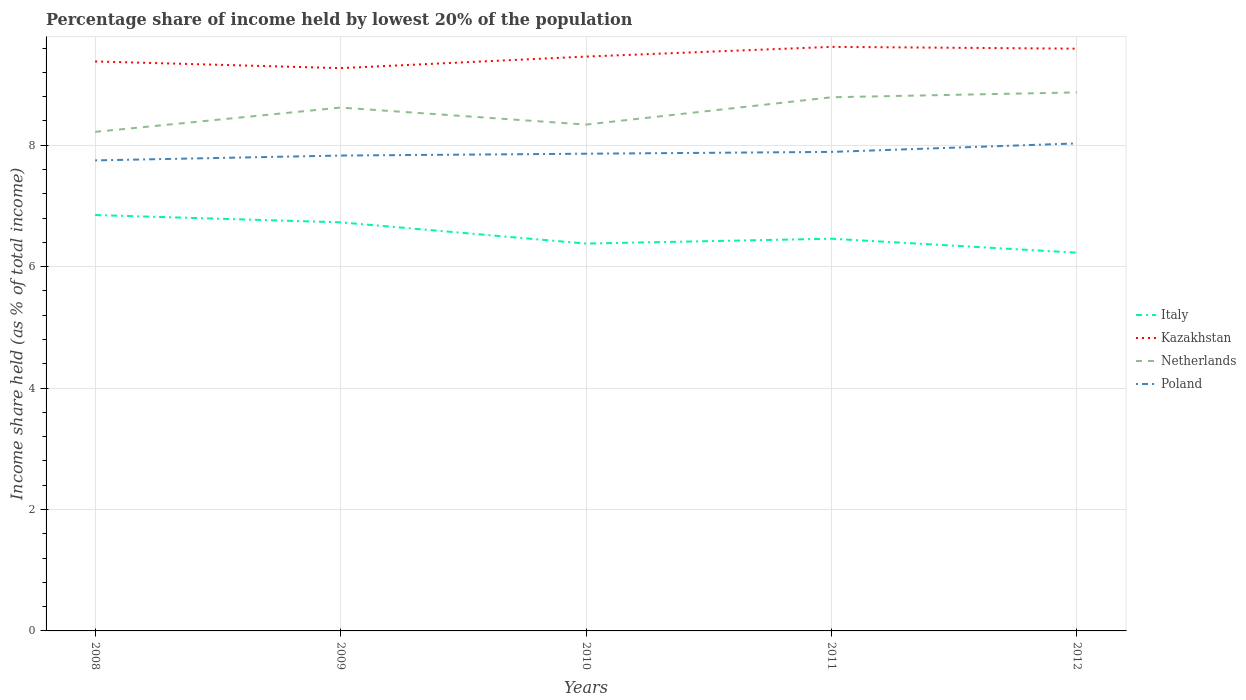Across all years, what is the maximum percentage share of income held by lowest 20% of the population in Italy?
Your response must be concise. 6.23. What is the total percentage share of income held by lowest 20% of the population in Netherlands in the graph?
Your answer should be compact. -0.12. What is the difference between the highest and the second highest percentage share of income held by lowest 20% of the population in Poland?
Your answer should be compact. 0.28. What is the difference between the highest and the lowest percentage share of income held by lowest 20% of the population in Kazakhstan?
Offer a terse response. 2. Is the percentage share of income held by lowest 20% of the population in Italy strictly greater than the percentage share of income held by lowest 20% of the population in Kazakhstan over the years?
Give a very brief answer. Yes. How many years are there in the graph?
Make the answer very short. 5. Are the values on the major ticks of Y-axis written in scientific E-notation?
Keep it short and to the point. No. Does the graph contain any zero values?
Keep it short and to the point. No. Where does the legend appear in the graph?
Provide a short and direct response. Center right. How many legend labels are there?
Ensure brevity in your answer.  4. How are the legend labels stacked?
Your answer should be compact. Vertical. What is the title of the graph?
Keep it short and to the point. Percentage share of income held by lowest 20% of the population. What is the label or title of the X-axis?
Keep it short and to the point. Years. What is the label or title of the Y-axis?
Give a very brief answer. Income share held (as % of total income). What is the Income share held (as % of total income) of Italy in 2008?
Offer a terse response. 6.85. What is the Income share held (as % of total income) of Kazakhstan in 2008?
Ensure brevity in your answer.  9.38. What is the Income share held (as % of total income) of Netherlands in 2008?
Your answer should be very brief. 8.22. What is the Income share held (as % of total income) of Poland in 2008?
Your response must be concise. 7.75. What is the Income share held (as % of total income) in Italy in 2009?
Ensure brevity in your answer.  6.73. What is the Income share held (as % of total income) in Kazakhstan in 2009?
Offer a terse response. 9.27. What is the Income share held (as % of total income) of Netherlands in 2009?
Provide a short and direct response. 8.62. What is the Income share held (as % of total income) of Poland in 2009?
Give a very brief answer. 7.83. What is the Income share held (as % of total income) of Italy in 2010?
Offer a very short reply. 6.38. What is the Income share held (as % of total income) in Kazakhstan in 2010?
Offer a terse response. 9.46. What is the Income share held (as % of total income) of Netherlands in 2010?
Your response must be concise. 8.34. What is the Income share held (as % of total income) in Poland in 2010?
Make the answer very short. 7.86. What is the Income share held (as % of total income) of Italy in 2011?
Your answer should be very brief. 6.46. What is the Income share held (as % of total income) in Kazakhstan in 2011?
Give a very brief answer. 9.62. What is the Income share held (as % of total income) in Netherlands in 2011?
Your answer should be compact. 8.79. What is the Income share held (as % of total income) of Poland in 2011?
Your answer should be very brief. 7.89. What is the Income share held (as % of total income) in Italy in 2012?
Give a very brief answer. 6.23. What is the Income share held (as % of total income) in Kazakhstan in 2012?
Provide a succinct answer. 9.59. What is the Income share held (as % of total income) in Netherlands in 2012?
Give a very brief answer. 8.87. What is the Income share held (as % of total income) in Poland in 2012?
Your response must be concise. 8.03. Across all years, what is the maximum Income share held (as % of total income) in Italy?
Your answer should be very brief. 6.85. Across all years, what is the maximum Income share held (as % of total income) in Kazakhstan?
Your answer should be very brief. 9.62. Across all years, what is the maximum Income share held (as % of total income) in Netherlands?
Give a very brief answer. 8.87. Across all years, what is the maximum Income share held (as % of total income) of Poland?
Provide a short and direct response. 8.03. Across all years, what is the minimum Income share held (as % of total income) of Italy?
Provide a succinct answer. 6.23. Across all years, what is the minimum Income share held (as % of total income) in Kazakhstan?
Keep it short and to the point. 9.27. Across all years, what is the minimum Income share held (as % of total income) of Netherlands?
Offer a very short reply. 8.22. Across all years, what is the minimum Income share held (as % of total income) in Poland?
Provide a succinct answer. 7.75. What is the total Income share held (as % of total income) in Italy in the graph?
Offer a very short reply. 32.65. What is the total Income share held (as % of total income) of Kazakhstan in the graph?
Your response must be concise. 47.32. What is the total Income share held (as % of total income) of Netherlands in the graph?
Provide a short and direct response. 42.84. What is the total Income share held (as % of total income) in Poland in the graph?
Offer a very short reply. 39.36. What is the difference between the Income share held (as % of total income) of Italy in 2008 and that in 2009?
Offer a terse response. 0.12. What is the difference between the Income share held (as % of total income) in Kazakhstan in 2008 and that in 2009?
Your response must be concise. 0.11. What is the difference between the Income share held (as % of total income) of Poland in 2008 and that in 2009?
Your response must be concise. -0.08. What is the difference between the Income share held (as % of total income) in Italy in 2008 and that in 2010?
Ensure brevity in your answer.  0.47. What is the difference between the Income share held (as % of total income) of Kazakhstan in 2008 and that in 2010?
Your answer should be compact. -0.08. What is the difference between the Income share held (as % of total income) in Netherlands in 2008 and that in 2010?
Your response must be concise. -0.12. What is the difference between the Income share held (as % of total income) of Poland in 2008 and that in 2010?
Offer a terse response. -0.11. What is the difference between the Income share held (as % of total income) in Italy in 2008 and that in 2011?
Offer a very short reply. 0.39. What is the difference between the Income share held (as % of total income) in Kazakhstan in 2008 and that in 2011?
Give a very brief answer. -0.24. What is the difference between the Income share held (as % of total income) of Netherlands in 2008 and that in 2011?
Your answer should be very brief. -0.57. What is the difference between the Income share held (as % of total income) in Poland in 2008 and that in 2011?
Your answer should be very brief. -0.14. What is the difference between the Income share held (as % of total income) of Italy in 2008 and that in 2012?
Provide a succinct answer. 0.62. What is the difference between the Income share held (as % of total income) of Kazakhstan in 2008 and that in 2012?
Give a very brief answer. -0.21. What is the difference between the Income share held (as % of total income) of Netherlands in 2008 and that in 2012?
Provide a short and direct response. -0.65. What is the difference between the Income share held (as % of total income) in Poland in 2008 and that in 2012?
Your response must be concise. -0.28. What is the difference between the Income share held (as % of total income) of Italy in 2009 and that in 2010?
Your answer should be very brief. 0.35. What is the difference between the Income share held (as % of total income) of Kazakhstan in 2009 and that in 2010?
Provide a short and direct response. -0.19. What is the difference between the Income share held (as % of total income) of Netherlands in 2009 and that in 2010?
Make the answer very short. 0.28. What is the difference between the Income share held (as % of total income) in Poland in 2009 and that in 2010?
Your answer should be compact. -0.03. What is the difference between the Income share held (as % of total income) of Italy in 2009 and that in 2011?
Your answer should be very brief. 0.27. What is the difference between the Income share held (as % of total income) in Kazakhstan in 2009 and that in 2011?
Offer a very short reply. -0.35. What is the difference between the Income share held (as % of total income) in Netherlands in 2009 and that in 2011?
Offer a terse response. -0.17. What is the difference between the Income share held (as % of total income) of Poland in 2009 and that in 2011?
Your answer should be very brief. -0.06. What is the difference between the Income share held (as % of total income) in Italy in 2009 and that in 2012?
Make the answer very short. 0.5. What is the difference between the Income share held (as % of total income) of Kazakhstan in 2009 and that in 2012?
Offer a terse response. -0.32. What is the difference between the Income share held (as % of total income) in Italy in 2010 and that in 2011?
Ensure brevity in your answer.  -0.08. What is the difference between the Income share held (as % of total income) of Kazakhstan in 2010 and that in 2011?
Give a very brief answer. -0.16. What is the difference between the Income share held (as % of total income) in Netherlands in 2010 and that in 2011?
Offer a terse response. -0.45. What is the difference between the Income share held (as % of total income) in Poland in 2010 and that in 2011?
Offer a terse response. -0.03. What is the difference between the Income share held (as % of total income) in Italy in 2010 and that in 2012?
Provide a succinct answer. 0.15. What is the difference between the Income share held (as % of total income) of Kazakhstan in 2010 and that in 2012?
Offer a very short reply. -0.13. What is the difference between the Income share held (as % of total income) of Netherlands in 2010 and that in 2012?
Your answer should be very brief. -0.53. What is the difference between the Income share held (as % of total income) in Poland in 2010 and that in 2012?
Offer a terse response. -0.17. What is the difference between the Income share held (as % of total income) in Italy in 2011 and that in 2012?
Your answer should be very brief. 0.23. What is the difference between the Income share held (as % of total income) of Kazakhstan in 2011 and that in 2012?
Ensure brevity in your answer.  0.03. What is the difference between the Income share held (as % of total income) in Netherlands in 2011 and that in 2012?
Keep it short and to the point. -0.08. What is the difference between the Income share held (as % of total income) in Poland in 2011 and that in 2012?
Your response must be concise. -0.14. What is the difference between the Income share held (as % of total income) in Italy in 2008 and the Income share held (as % of total income) in Kazakhstan in 2009?
Your answer should be very brief. -2.42. What is the difference between the Income share held (as % of total income) of Italy in 2008 and the Income share held (as % of total income) of Netherlands in 2009?
Make the answer very short. -1.77. What is the difference between the Income share held (as % of total income) in Italy in 2008 and the Income share held (as % of total income) in Poland in 2009?
Give a very brief answer. -0.98. What is the difference between the Income share held (as % of total income) of Kazakhstan in 2008 and the Income share held (as % of total income) of Netherlands in 2009?
Keep it short and to the point. 0.76. What is the difference between the Income share held (as % of total income) in Kazakhstan in 2008 and the Income share held (as % of total income) in Poland in 2009?
Your response must be concise. 1.55. What is the difference between the Income share held (as % of total income) of Netherlands in 2008 and the Income share held (as % of total income) of Poland in 2009?
Your answer should be compact. 0.39. What is the difference between the Income share held (as % of total income) in Italy in 2008 and the Income share held (as % of total income) in Kazakhstan in 2010?
Your response must be concise. -2.61. What is the difference between the Income share held (as % of total income) in Italy in 2008 and the Income share held (as % of total income) in Netherlands in 2010?
Your answer should be compact. -1.49. What is the difference between the Income share held (as % of total income) of Italy in 2008 and the Income share held (as % of total income) of Poland in 2010?
Ensure brevity in your answer.  -1.01. What is the difference between the Income share held (as % of total income) in Kazakhstan in 2008 and the Income share held (as % of total income) in Netherlands in 2010?
Your answer should be very brief. 1.04. What is the difference between the Income share held (as % of total income) of Kazakhstan in 2008 and the Income share held (as % of total income) of Poland in 2010?
Your answer should be very brief. 1.52. What is the difference between the Income share held (as % of total income) of Netherlands in 2008 and the Income share held (as % of total income) of Poland in 2010?
Your response must be concise. 0.36. What is the difference between the Income share held (as % of total income) of Italy in 2008 and the Income share held (as % of total income) of Kazakhstan in 2011?
Offer a very short reply. -2.77. What is the difference between the Income share held (as % of total income) of Italy in 2008 and the Income share held (as % of total income) of Netherlands in 2011?
Your answer should be very brief. -1.94. What is the difference between the Income share held (as % of total income) in Italy in 2008 and the Income share held (as % of total income) in Poland in 2011?
Provide a short and direct response. -1.04. What is the difference between the Income share held (as % of total income) in Kazakhstan in 2008 and the Income share held (as % of total income) in Netherlands in 2011?
Keep it short and to the point. 0.59. What is the difference between the Income share held (as % of total income) of Kazakhstan in 2008 and the Income share held (as % of total income) of Poland in 2011?
Offer a terse response. 1.49. What is the difference between the Income share held (as % of total income) in Netherlands in 2008 and the Income share held (as % of total income) in Poland in 2011?
Ensure brevity in your answer.  0.33. What is the difference between the Income share held (as % of total income) in Italy in 2008 and the Income share held (as % of total income) in Kazakhstan in 2012?
Your response must be concise. -2.74. What is the difference between the Income share held (as % of total income) in Italy in 2008 and the Income share held (as % of total income) in Netherlands in 2012?
Offer a terse response. -2.02. What is the difference between the Income share held (as % of total income) of Italy in 2008 and the Income share held (as % of total income) of Poland in 2012?
Keep it short and to the point. -1.18. What is the difference between the Income share held (as % of total income) in Kazakhstan in 2008 and the Income share held (as % of total income) in Netherlands in 2012?
Offer a very short reply. 0.51. What is the difference between the Income share held (as % of total income) in Kazakhstan in 2008 and the Income share held (as % of total income) in Poland in 2012?
Offer a very short reply. 1.35. What is the difference between the Income share held (as % of total income) of Netherlands in 2008 and the Income share held (as % of total income) of Poland in 2012?
Your answer should be very brief. 0.19. What is the difference between the Income share held (as % of total income) of Italy in 2009 and the Income share held (as % of total income) of Kazakhstan in 2010?
Your response must be concise. -2.73. What is the difference between the Income share held (as % of total income) of Italy in 2009 and the Income share held (as % of total income) of Netherlands in 2010?
Ensure brevity in your answer.  -1.61. What is the difference between the Income share held (as % of total income) of Italy in 2009 and the Income share held (as % of total income) of Poland in 2010?
Make the answer very short. -1.13. What is the difference between the Income share held (as % of total income) in Kazakhstan in 2009 and the Income share held (as % of total income) in Netherlands in 2010?
Offer a very short reply. 0.93. What is the difference between the Income share held (as % of total income) of Kazakhstan in 2009 and the Income share held (as % of total income) of Poland in 2010?
Keep it short and to the point. 1.41. What is the difference between the Income share held (as % of total income) of Netherlands in 2009 and the Income share held (as % of total income) of Poland in 2010?
Provide a succinct answer. 0.76. What is the difference between the Income share held (as % of total income) in Italy in 2009 and the Income share held (as % of total income) in Kazakhstan in 2011?
Your answer should be very brief. -2.89. What is the difference between the Income share held (as % of total income) in Italy in 2009 and the Income share held (as % of total income) in Netherlands in 2011?
Make the answer very short. -2.06. What is the difference between the Income share held (as % of total income) of Italy in 2009 and the Income share held (as % of total income) of Poland in 2011?
Offer a very short reply. -1.16. What is the difference between the Income share held (as % of total income) of Kazakhstan in 2009 and the Income share held (as % of total income) of Netherlands in 2011?
Give a very brief answer. 0.48. What is the difference between the Income share held (as % of total income) in Kazakhstan in 2009 and the Income share held (as % of total income) in Poland in 2011?
Your response must be concise. 1.38. What is the difference between the Income share held (as % of total income) of Netherlands in 2009 and the Income share held (as % of total income) of Poland in 2011?
Make the answer very short. 0.73. What is the difference between the Income share held (as % of total income) of Italy in 2009 and the Income share held (as % of total income) of Kazakhstan in 2012?
Your response must be concise. -2.86. What is the difference between the Income share held (as % of total income) of Italy in 2009 and the Income share held (as % of total income) of Netherlands in 2012?
Keep it short and to the point. -2.14. What is the difference between the Income share held (as % of total income) in Kazakhstan in 2009 and the Income share held (as % of total income) in Netherlands in 2012?
Keep it short and to the point. 0.4. What is the difference between the Income share held (as % of total income) in Kazakhstan in 2009 and the Income share held (as % of total income) in Poland in 2012?
Give a very brief answer. 1.24. What is the difference between the Income share held (as % of total income) in Netherlands in 2009 and the Income share held (as % of total income) in Poland in 2012?
Offer a terse response. 0.59. What is the difference between the Income share held (as % of total income) of Italy in 2010 and the Income share held (as % of total income) of Kazakhstan in 2011?
Provide a succinct answer. -3.24. What is the difference between the Income share held (as % of total income) of Italy in 2010 and the Income share held (as % of total income) of Netherlands in 2011?
Make the answer very short. -2.41. What is the difference between the Income share held (as % of total income) of Italy in 2010 and the Income share held (as % of total income) of Poland in 2011?
Ensure brevity in your answer.  -1.51. What is the difference between the Income share held (as % of total income) in Kazakhstan in 2010 and the Income share held (as % of total income) in Netherlands in 2011?
Your response must be concise. 0.67. What is the difference between the Income share held (as % of total income) of Kazakhstan in 2010 and the Income share held (as % of total income) of Poland in 2011?
Offer a terse response. 1.57. What is the difference between the Income share held (as % of total income) of Netherlands in 2010 and the Income share held (as % of total income) of Poland in 2011?
Ensure brevity in your answer.  0.45. What is the difference between the Income share held (as % of total income) of Italy in 2010 and the Income share held (as % of total income) of Kazakhstan in 2012?
Provide a succinct answer. -3.21. What is the difference between the Income share held (as % of total income) of Italy in 2010 and the Income share held (as % of total income) of Netherlands in 2012?
Offer a terse response. -2.49. What is the difference between the Income share held (as % of total income) of Italy in 2010 and the Income share held (as % of total income) of Poland in 2012?
Provide a succinct answer. -1.65. What is the difference between the Income share held (as % of total income) of Kazakhstan in 2010 and the Income share held (as % of total income) of Netherlands in 2012?
Keep it short and to the point. 0.59. What is the difference between the Income share held (as % of total income) of Kazakhstan in 2010 and the Income share held (as % of total income) of Poland in 2012?
Ensure brevity in your answer.  1.43. What is the difference between the Income share held (as % of total income) of Netherlands in 2010 and the Income share held (as % of total income) of Poland in 2012?
Your answer should be very brief. 0.31. What is the difference between the Income share held (as % of total income) of Italy in 2011 and the Income share held (as % of total income) of Kazakhstan in 2012?
Your answer should be very brief. -3.13. What is the difference between the Income share held (as % of total income) in Italy in 2011 and the Income share held (as % of total income) in Netherlands in 2012?
Offer a very short reply. -2.41. What is the difference between the Income share held (as % of total income) in Italy in 2011 and the Income share held (as % of total income) in Poland in 2012?
Keep it short and to the point. -1.57. What is the difference between the Income share held (as % of total income) in Kazakhstan in 2011 and the Income share held (as % of total income) in Netherlands in 2012?
Offer a very short reply. 0.75. What is the difference between the Income share held (as % of total income) of Kazakhstan in 2011 and the Income share held (as % of total income) of Poland in 2012?
Make the answer very short. 1.59. What is the difference between the Income share held (as % of total income) in Netherlands in 2011 and the Income share held (as % of total income) in Poland in 2012?
Offer a terse response. 0.76. What is the average Income share held (as % of total income) in Italy per year?
Make the answer very short. 6.53. What is the average Income share held (as % of total income) in Kazakhstan per year?
Keep it short and to the point. 9.46. What is the average Income share held (as % of total income) of Netherlands per year?
Offer a very short reply. 8.57. What is the average Income share held (as % of total income) in Poland per year?
Ensure brevity in your answer.  7.87. In the year 2008, what is the difference between the Income share held (as % of total income) in Italy and Income share held (as % of total income) in Kazakhstan?
Your response must be concise. -2.53. In the year 2008, what is the difference between the Income share held (as % of total income) of Italy and Income share held (as % of total income) of Netherlands?
Ensure brevity in your answer.  -1.37. In the year 2008, what is the difference between the Income share held (as % of total income) of Kazakhstan and Income share held (as % of total income) of Netherlands?
Provide a short and direct response. 1.16. In the year 2008, what is the difference between the Income share held (as % of total income) of Kazakhstan and Income share held (as % of total income) of Poland?
Make the answer very short. 1.63. In the year 2008, what is the difference between the Income share held (as % of total income) of Netherlands and Income share held (as % of total income) of Poland?
Your answer should be compact. 0.47. In the year 2009, what is the difference between the Income share held (as % of total income) in Italy and Income share held (as % of total income) in Kazakhstan?
Give a very brief answer. -2.54. In the year 2009, what is the difference between the Income share held (as % of total income) of Italy and Income share held (as % of total income) of Netherlands?
Your response must be concise. -1.89. In the year 2009, what is the difference between the Income share held (as % of total income) of Italy and Income share held (as % of total income) of Poland?
Ensure brevity in your answer.  -1.1. In the year 2009, what is the difference between the Income share held (as % of total income) of Kazakhstan and Income share held (as % of total income) of Netherlands?
Your answer should be compact. 0.65. In the year 2009, what is the difference between the Income share held (as % of total income) of Kazakhstan and Income share held (as % of total income) of Poland?
Your answer should be very brief. 1.44. In the year 2009, what is the difference between the Income share held (as % of total income) of Netherlands and Income share held (as % of total income) of Poland?
Your answer should be very brief. 0.79. In the year 2010, what is the difference between the Income share held (as % of total income) of Italy and Income share held (as % of total income) of Kazakhstan?
Offer a very short reply. -3.08. In the year 2010, what is the difference between the Income share held (as % of total income) of Italy and Income share held (as % of total income) of Netherlands?
Provide a short and direct response. -1.96. In the year 2010, what is the difference between the Income share held (as % of total income) of Italy and Income share held (as % of total income) of Poland?
Make the answer very short. -1.48. In the year 2010, what is the difference between the Income share held (as % of total income) in Kazakhstan and Income share held (as % of total income) in Netherlands?
Your answer should be compact. 1.12. In the year 2010, what is the difference between the Income share held (as % of total income) in Netherlands and Income share held (as % of total income) in Poland?
Give a very brief answer. 0.48. In the year 2011, what is the difference between the Income share held (as % of total income) in Italy and Income share held (as % of total income) in Kazakhstan?
Make the answer very short. -3.16. In the year 2011, what is the difference between the Income share held (as % of total income) of Italy and Income share held (as % of total income) of Netherlands?
Provide a short and direct response. -2.33. In the year 2011, what is the difference between the Income share held (as % of total income) in Italy and Income share held (as % of total income) in Poland?
Your answer should be compact. -1.43. In the year 2011, what is the difference between the Income share held (as % of total income) of Kazakhstan and Income share held (as % of total income) of Netherlands?
Offer a terse response. 0.83. In the year 2011, what is the difference between the Income share held (as % of total income) in Kazakhstan and Income share held (as % of total income) in Poland?
Give a very brief answer. 1.73. In the year 2012, what is the difference between the Income share held (as % of total income) of Italy and Income share held (as % of total income) of Kazakhstan?
Give a very brief answer. -3.36. In the year 2012, what is the difference between the Income share held (as % of total income) in Italy and Income share held (as % of total income) in Netherlands?
Your response must be concise. -2.64. In the year 2012, what is the difference between the Income share held (as % of total income) in Kazakhstan and Income share held (as % of total income) in Netherlands?
Your answer should be compact. 0.72. In the year 2012, what is the difference between the Income share held (as % of total income) in Kazakhstan and Income share held (as % of total income) in Poland?
Your response must be concise. 1.56. In the year 2012, what is the difference between the Income share held (as % of total income) in Netherlands and Income share held (as % of total income) in Poland?
Make the answer very short. 0.84. What is the ratio of the Income share held (as % of total income) of Italy in 2008 to that in 2009?
Keep it short and to the point. 1.02. What is the ratio of the Income share held (as % of total income) in Kazakhstan in 2008 to that in 2009?
Make the answer very short. 1.01. What is the ratio of the Income share held (as % of total income) in Netherlands in 2008 to that in 2009?
Ensure brevity in your answer.  0.95. What is the ratio of the Income share held (as % of total income) of Italy in 2008 to that in 2010?
Make the answer very short. 1.07. What is the ratio of the Income share held (as % of total income) in Kazakhstan in 2008 to that in 2010?
Give a very brief answer. 0.99. What is the ratio of the Income share held (as % of total income) in Netherlands in 2008 to that in 2010?
Make the answer very short. 0.99. What is the ratio of the Income share held (as % of total income) in Italy in 2008 to that in 2011?
Ensure brevity in your answer.  1.06. What is the ratio of the Income share held (as % of total income) in Kazakhstan in 2008 to that in 2011?
Your answer should be compact. 0.98. What is the ratio of the Income share held (as % of total income) of Netherlands in 2008 to that in 2011?
Keep it short and to the point. 0.94. What is the ratio of the Income share held (as % of total income) of Poland in 2008 to that in 2011?
Your response must be concise. 0.98. What is the ratio of the Income share held (as % of total income) of Italy in 2008 to that in 2012?
Keep it short and to the point. 1.1. What is the ratio of the Income share held (as % of total income) of Kazakhstan in 2008 to that in 2012?
Make the answer very short. 0.98. What is the ratio of the Income share held (as % of total income) of Netherlands in 2008 to that in 2012?
Your response must be concise. 0.93. What is the ratio of the Income share held (as % of total income) of Poland in 2008 to that in 2012?
Make the answer very short. 0.97. What is the ratio of the Income share held (as % of total income) in Italy in 2009 to that in 2010?
Your response must be concise. 1.05. What is the ratio of the Income share held (as % of total income) in Kazakhstan in 2009 to that in 2010?
Provide a succinct answer. 0.98. What is the ratio of the Income share held (as % of total income) in Netherlands in 2009 to that in 2010?
Your answer should be very brief. 1.03. What is the ratio of the Income share held (as % of total income) in Poland in 2009 to that in 2010?
Provide a short and direct response. 1. What is the ratio of the Income share held (as % of total income) of Italy in 2009 to that in 2011?
Your answer should be compact. 1.04. What is the ratio of the Income share held (as % of total income) in Kazakhstan in 2009 to that in 2011?
Provide a succinct answer. 0.96. What is the ratio of the Income share held (as % of total income) of Netherlands in 2009 to that in 2011?
Your answer should be very brief. 0.98. What is the ratio of the Income share held (as % of total income) in Poland in 2009 to that in 2011?
Offer a very short reply. 0.99. What is the ratio of the Income share held (as % of total income) in Italy in 2009 to that in 2012?
Your answer should be compact. 1.08. What is the ratio of the Income share held (as % of total income) of Kazakhstan in 2009 to that in 2012?
Your answer should be very brief. 0.97. What is the ratio of the Income share held (as % of total income) of Netherlands in 2009 to that in 2012?
Your answer should be very brief. 0.97. What is the ratio of the Income share held (as % of total income) in Poland in 2009 to that in 2012?
Your response must be concise. 0.98. What is the ratio of the Income share held (as % of total income) of Italy in 2010 to that in 2011?
Offer a terse response. 0.99. What is the ratio of the Income share held (as % of total income) of Kazakhstan in 2010 to that in 2011?
Give a very brief answer. 0.98. What is the ratio of the Income share held (as % of total income) of Netherlands in 2010 to that in 2011?
Make the answer very short. 0.95. What is the ratio of the Income share held (as % of total income) in Italy in 2010 to that in 2012?
Offer a terse response. 1.02. What is the ratio of the Income share held (as % of total income) in Kazakhstan in 2010 to that in 2012?
Offer a very short reply. 0.99. What is the ratio of the Income share held (as % of total income) in Netherlands in 2010 to that in 2012?
Offer a very short reply. 0.94. What is the ratio of the Income share held (as % of total income) in Poland in 2010 to that in 2012?
Make the answer very short. 0.98. What is the ratio of the Income share held (as % of total income) in Italy in 2011 to that in 2012?
Offer a terse response. 1.04. What is the ratio of the Income share held (as % of total income) in Kazakhstan in 2011 to that in 2012?
Ensure brevity in your answer.  1. What is the ratio of the Income share held (as % of total income) in Poland in 2011 to that in 2012?
Your answer should be very brief. 0.98. What is the difference between the highest and the second highest Income share held (as % of total income) of Italy?
Provide a short and direct response. 0.12. What is the difference between the highest and the second highest Income share held (as % of total income) of Netherlands?
Your response must be concise. 0.08. What is the difference between the highest and the second highest Income share held (as % of total income) in Poland?
Give a very brief answer. 0.14. What is the difference between the highest and the lowest Income share held (as % of total income) of Italy?
Ensure brevity in your answer.  0.62. What is the difference between the highest and the lowest Income share held (as % of total income) of Netherlands?
Offer a very short reply. 0.65. What is the difference between the highest and the lowest Income share held (as % of total income) in Poland?
Provide a short and direct response. 0.28. 